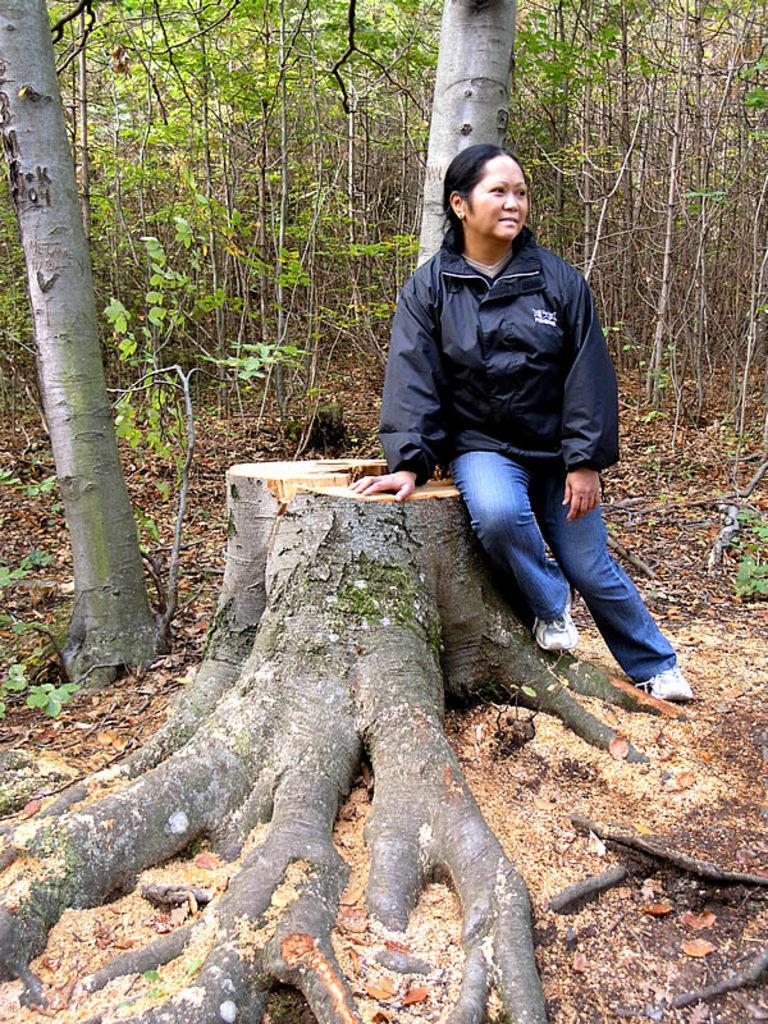Please provide a concise description of this image. In this picture there is a woman who is wearing black jacket, t shirt, jeans and he is sitting on this wood. In the background we can see many trees. At the bottom we can see the leaves. 